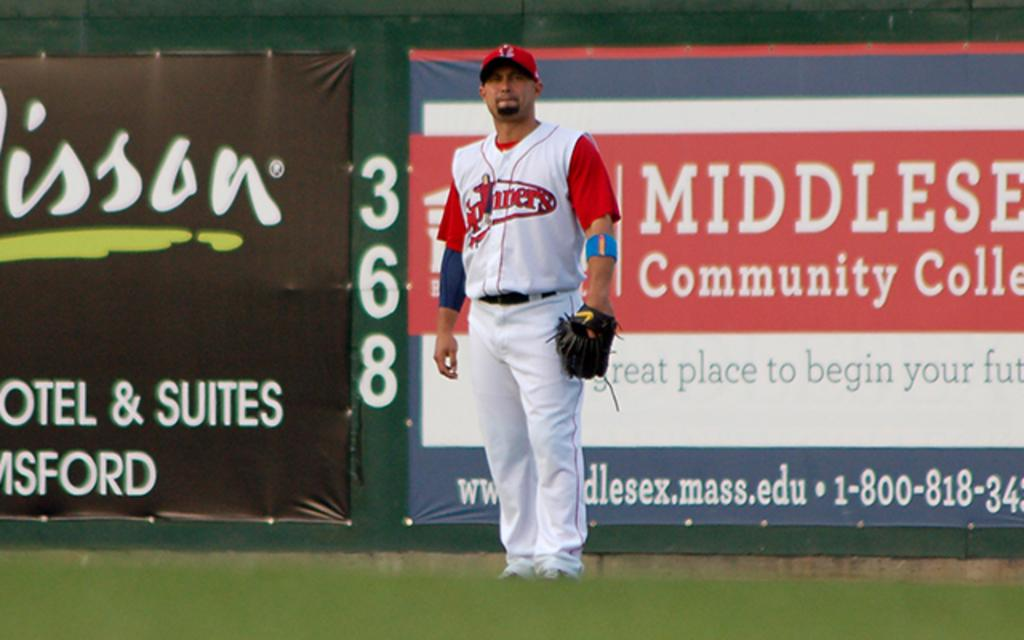Provide a one-sentence caption for the provided image. Baseball player standing in front of an ad for a Community College. 